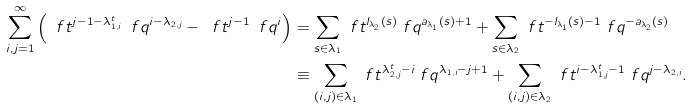Convert formula to latex. <formula><loc_0><loc_0><loc_500><loc_500>\sum _ { i , j = 1 } ^ { \infty } \left ( \ f t ^ { j - 1 - \lambda _ { 1 , i } ^ { t } } \ f q ^ { i - \lambda _ { 2 , j } } - \ f t ^ { j - 1 } \ f q ^ { i } \right ) & = \sum _ { s \in \lambda _ { 1 } } \ f t ^ { l _ { \lambda _ { 2 } } ( s ) } \ f q ^ { a _ { \lambda _ { 1 } } ( s ) + 1 } + \sum _ { s \in \lambda _ { 2 } } \ f t ^ { - l _ { \lambda _ { 1 } } ( s ) - 1 } \ f q ^ { - a _ { \lambda _ { 2 } } ( s ) } \\ & \equiv \sum _ { ( i , j ) \in \lambda _ { 1 } } \ f t ^ { \lambda _ { 2 , j } ^ { t } - i } \ f q ^ { \lambda _ { 1 , i } - j + 1 } + \sum _ { ( i , j ) \in \lambda _ { 2 } } \ f t ^ { i - \lambda _ { 1 , j } ^ { t } - 1 } \ f q ^ { j - \lambda _ { 2 , i } } .</formula> 